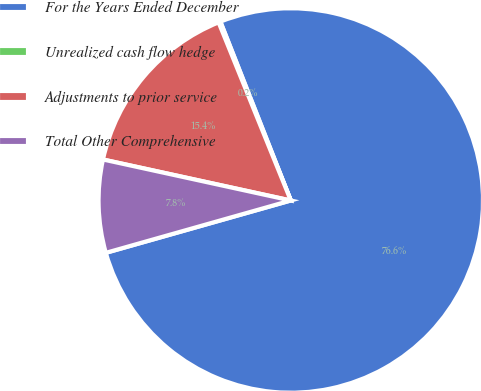Convert chart. <chart><loc_0><loc_0><loc_500><loc_500><pie_chart><fcel>For the Years Ended December<fcel>Unrealized cash flow hedge<fcel>Adjustments to prior service<fcel>Total Other Comprehensive<nl><fcel>76.58%<fcel>0.16%<fcel>15.45%<fcel>7.81%<nl></chart> 